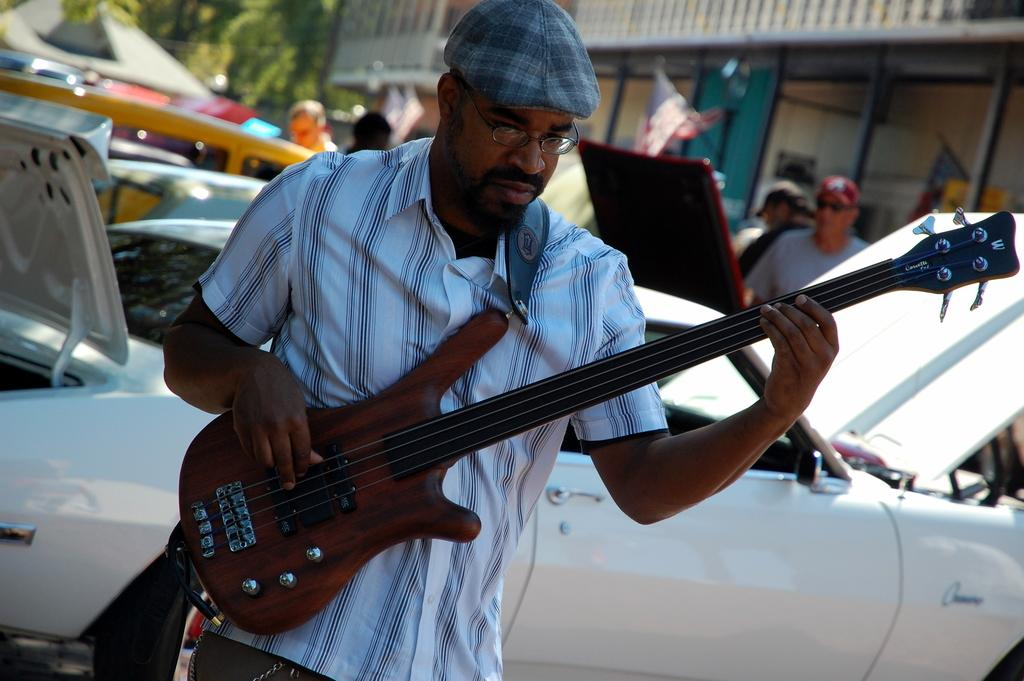What is the main subject of the image? There is a person standing at the center of the image. the image. What is the person holding in his hand? The person is holding a guitar in his hand. What can be seen in the background of the image? There is a car in the background of the image. Can you describe the other person visible in the image? There is another person on the top right of the image. What additional detail can be observed in the image? There is a flag visible in the image. How far away is the slave from the person holding the guitar in the image? There is no slave present in the image, so it is not possible to determine the distance between a slave and the person holding the guitar. 